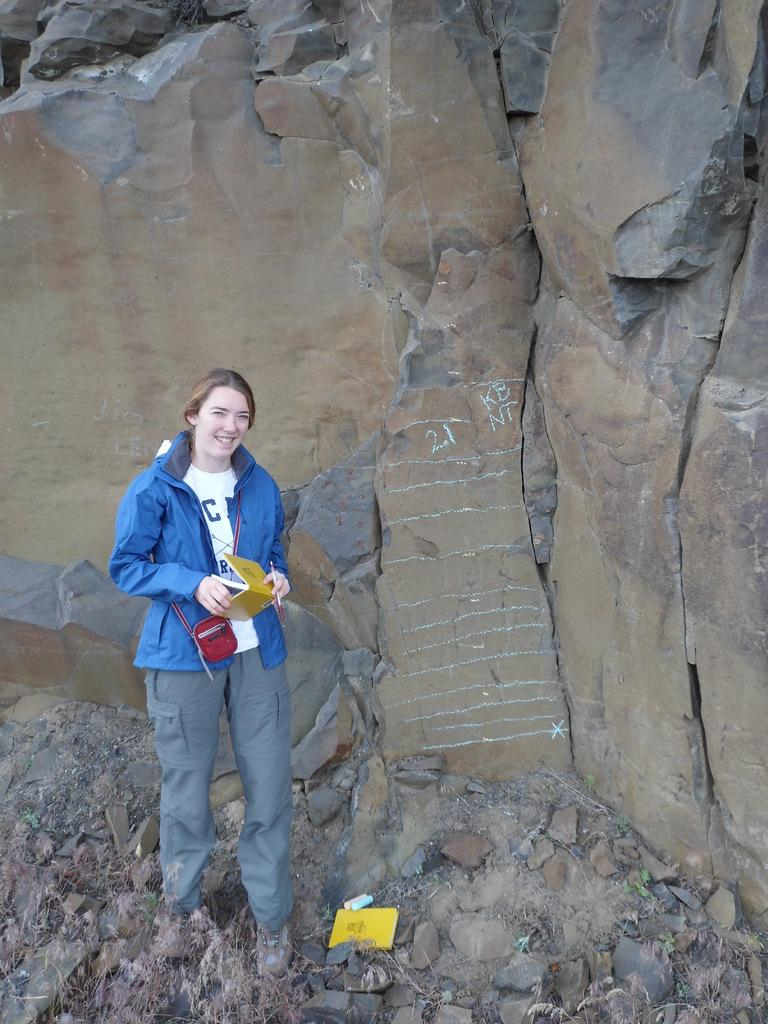What can be seen in the foreground of the image? There are stones and a woman in the foreground of the image. What is the woman holding in the image? The woman is holding a book. What can be seen in the background of the image? There is a rock in the background of the image. What type of coal can be seen in the image? There is no coal present in the image. How comfortable is the woman sitting on the stones in the image? The image does not provide information about the comfort level of the woman sitting on the stones. 